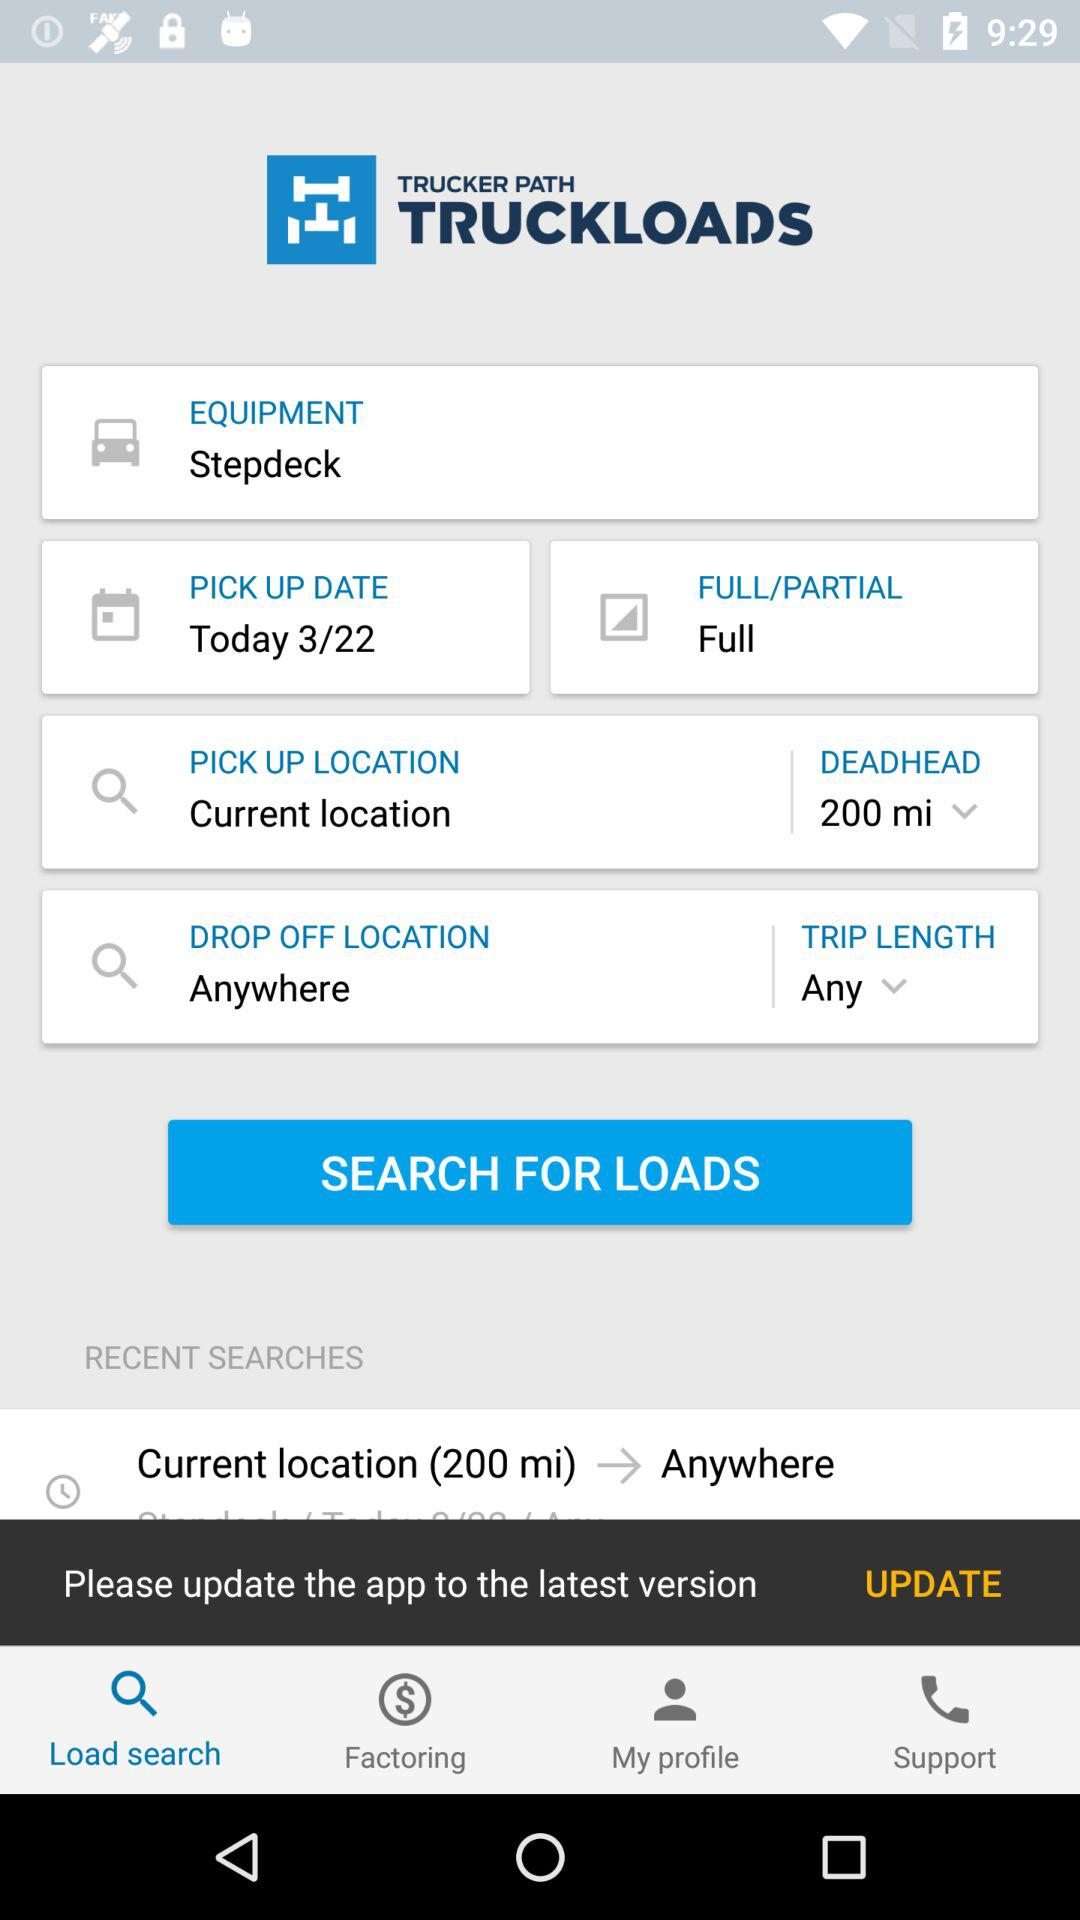What type of equipment is used for the truckload? The type of equipment is "Stepdeck". 